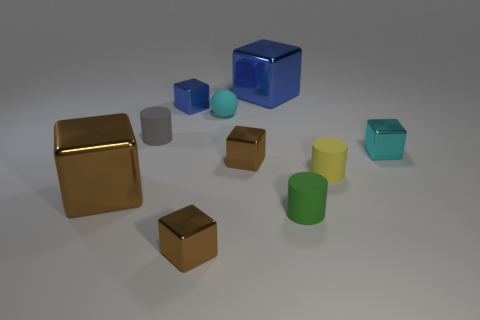Does the brown cube that is right of the ball have the same size as the small blue metal block?
Keep it short and to the point. Yes. There is a yellow thing that is on the left side of the tiny cyan metallic cube; what is its shape?
Your answer should be very brief. Cylinder. Are there more blue blocks than tiny things?
Make the answer very short. No. Is the color of the small metal thing on the right side of the tiny green object the same as the small sphere?
Give a very brief answer. Yes. How many objects are shiny objects that are behind the yellow matte object or small metal cubes behind the yellow rubber cylinder?
Provide a succinct answer. 4. How many cylinders are both in front of the yellow thing and behind the green rubber cylinder?
Your answer should be compact. 0. Do the small blue object and the small cyan sphere have the same material?
Your answer should be very brief. No. What is the shape of the tiny blue object that is left of the tiny cyan object to the left of the blue metal block on the right side of the small blue shiny cube?
Ensure brevity in your answer.  Cube. There is a small cube that is both in front of the tiny blue cube and on the left side of the small sphere; what material is it made of?
Offer a terse response. Metal. There is a small object that is left of the blue metallic cube that is to the left of the large cube that is behind the tiny blue shiny block; what color is it?
Make the answer very short. Gray. 